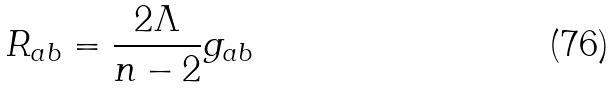<formula> <loc_0><loc_0><loc_500><loc_500>R _ { a b } = \frac { 2 \Lambda } { n - 2 } g _ { a b }</formula> 